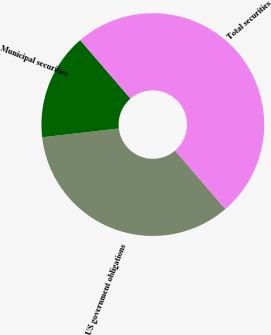<chart> <loc_0><loc_0><loc_500><loc_500><pie_chart><fcel>US government obligations<fcel>Municipal securities<fcel>Total securities<nl><fcel>34.48%<fcel>15.52%<fcel>50.0%<nl></chart> 